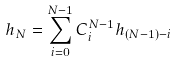Convert formula to latex. <formula><loc_0><loc_0><loc_500><loc_500>h _ { N } = \sum _ { i = 0 } ^ { N - 1 } C _ { i } ^ { N - 1 } h _ { ( N - 1 ) - i }</formula> 